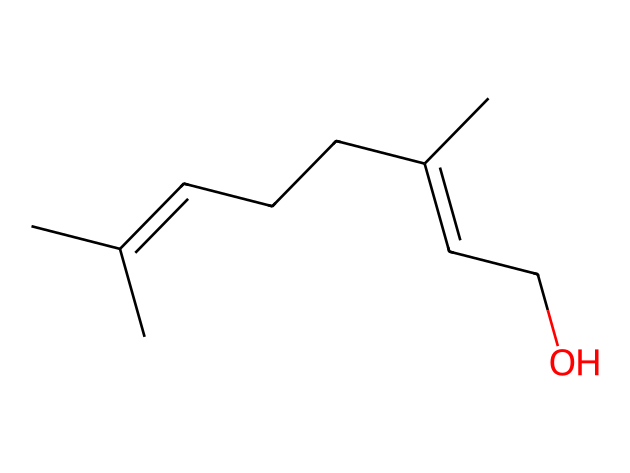What is the main functional group in this chemical structure? The chemical structure contains a hydroxyl group (-OH) attached to a carbon chain, indicating the presence of alcohols in its structure.
Answer: hydroxyl group How many carbon atoms are present in this molecule? By analyzing the SMILES representation, we can count the number of carbon atoms (C) represented in the structure. There are 10 carbon atoms in total.
Answer: 10 What is the saturation level of this chemical compound? The presence of double bonds in the carbon chain indicates that this chemical is unsaturated. Unsaturated compounds contain one or more double bonds between carbon atoms.
Answer: unsaturated Which component of this chemical contributes to its insect-repelling properties? The hydrocarbon structure, particularly the presence of certain double bonds in the structure, is key for insect-repelling properties, as these features are typical in natural insect repellents like citronella.
Answer: hydrocarbon structure How many double bonds are present in the chemical structure? By analyzing the connections in the SMILES representation, we can identify the double bonds present. There are two double bonds in the structure.
Answer: 2 What type of chemical is citronella oil classified as? Citronella oil is derived from plant extracts and is classified as a natural insect repellent, which primarily consists of terpenes and alcohols based on its composition.
Answer: natural insect repellent 